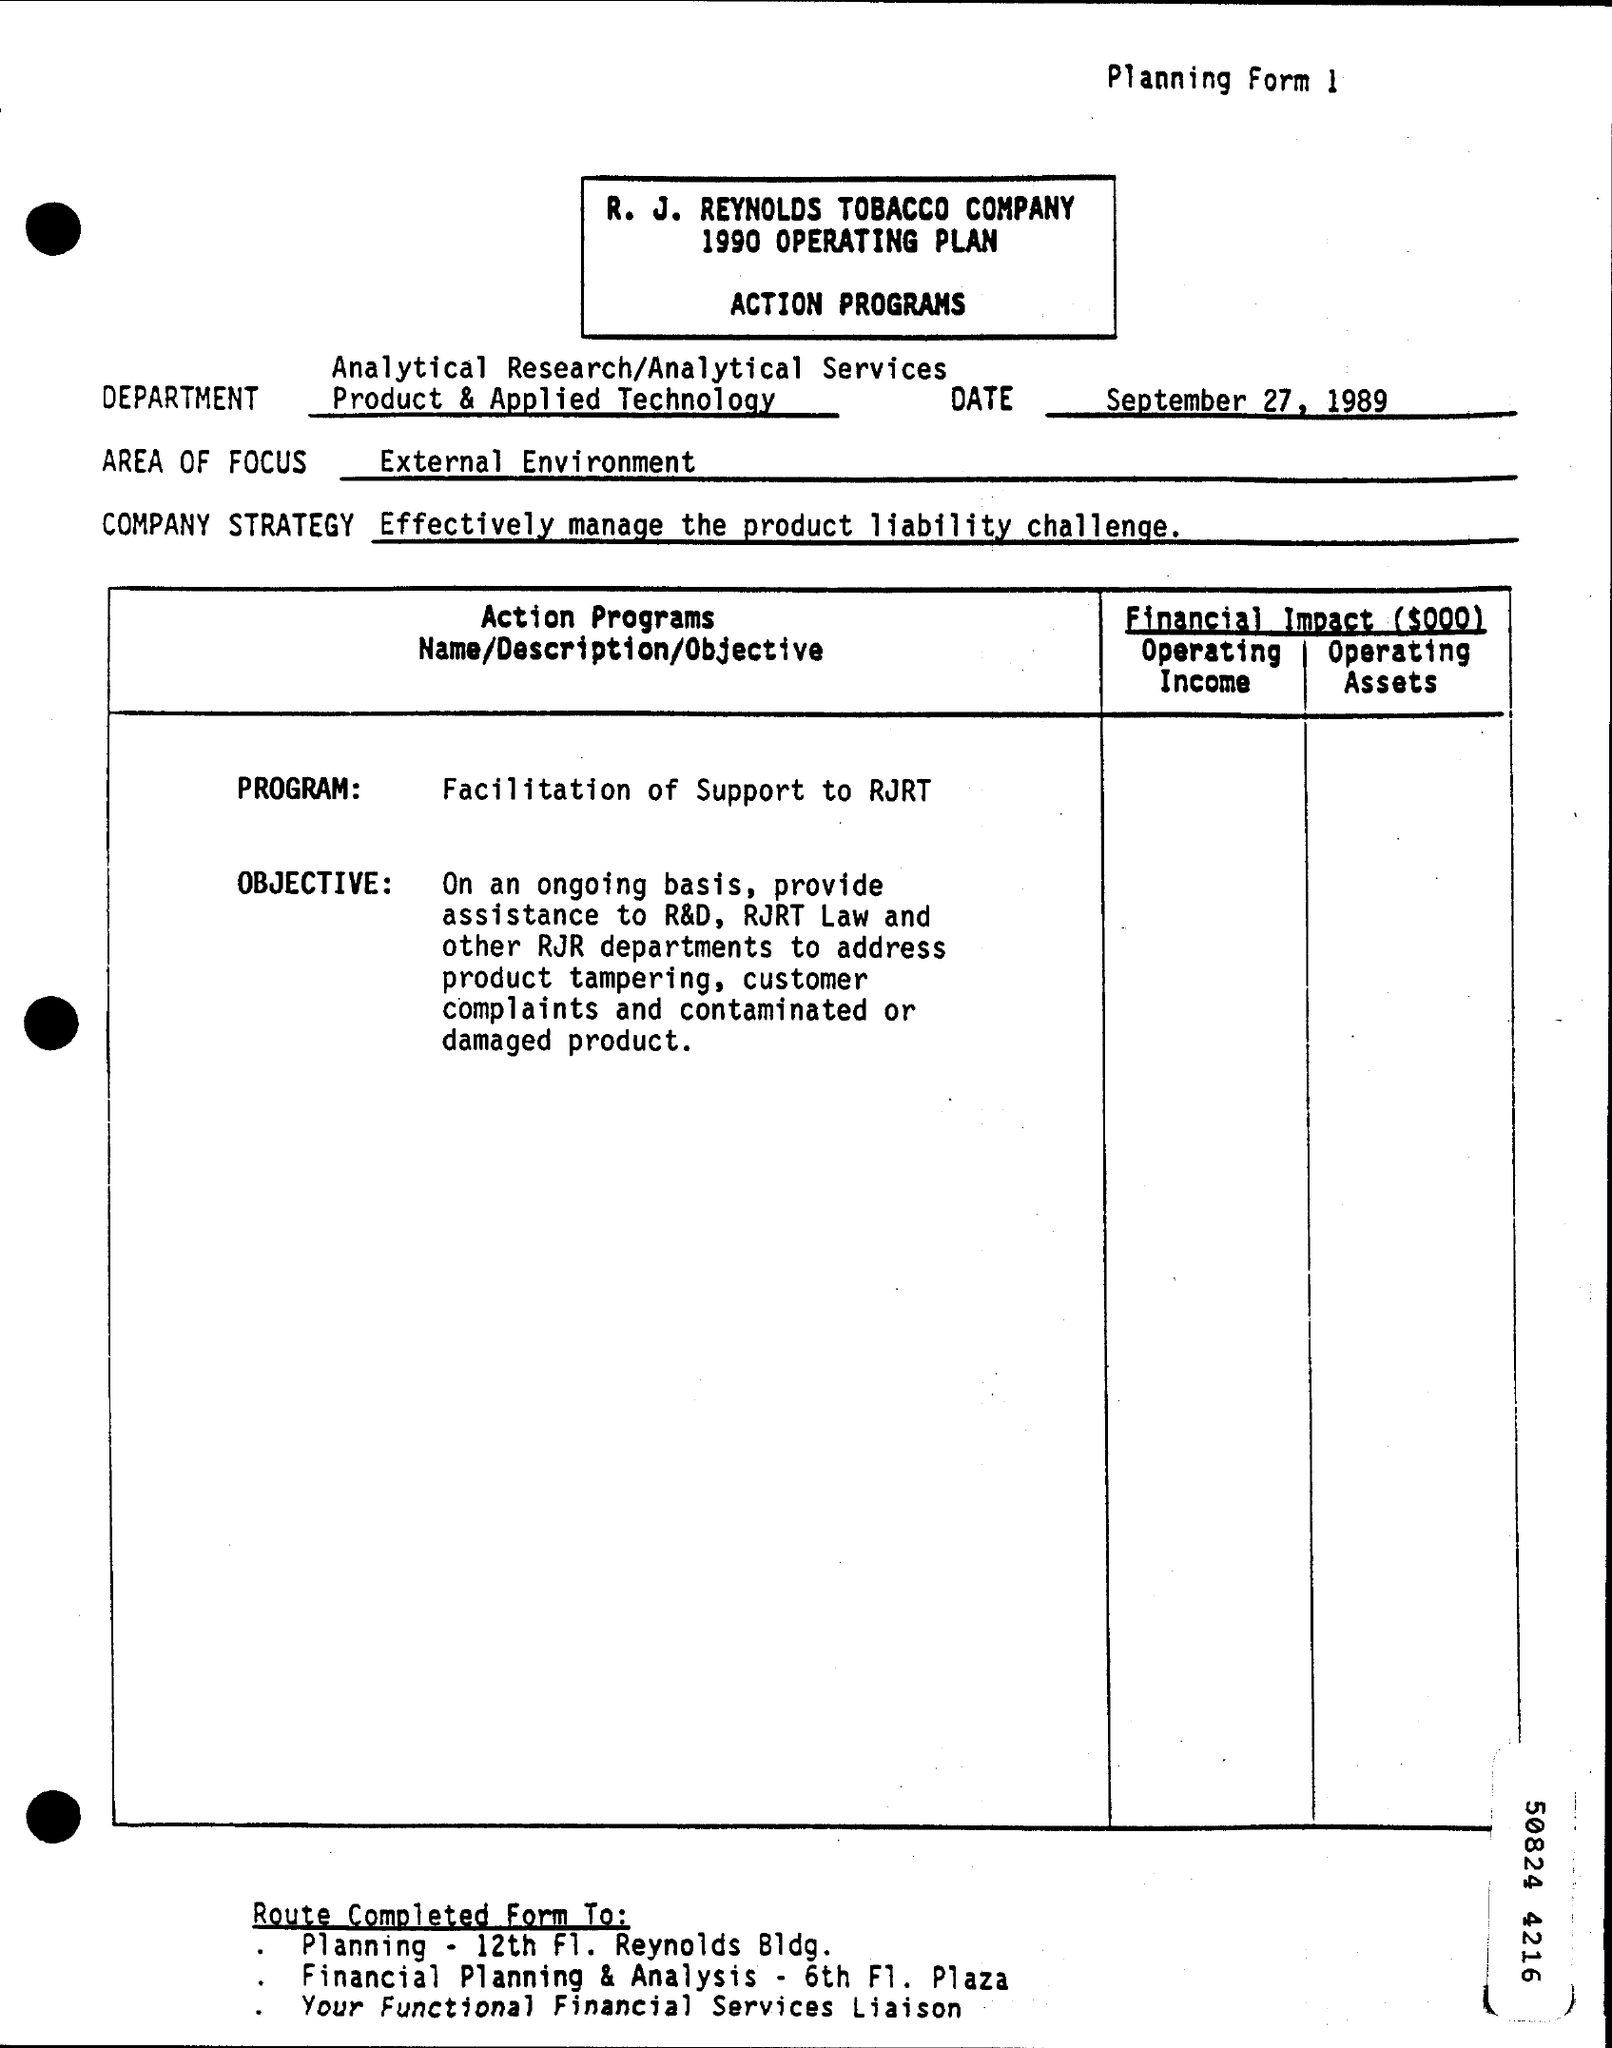Indicate a few pertinent items in this graphic. The Planning form mentions that the date is September 27, 1989. The Area of Focus mentioned in the Planning form is the external environment. The action program name, as specified in the planning form, is "Facilitation of Support to RJRT. The company strategy mentioned in the planning form is to effectively manage the product liability challenge. 